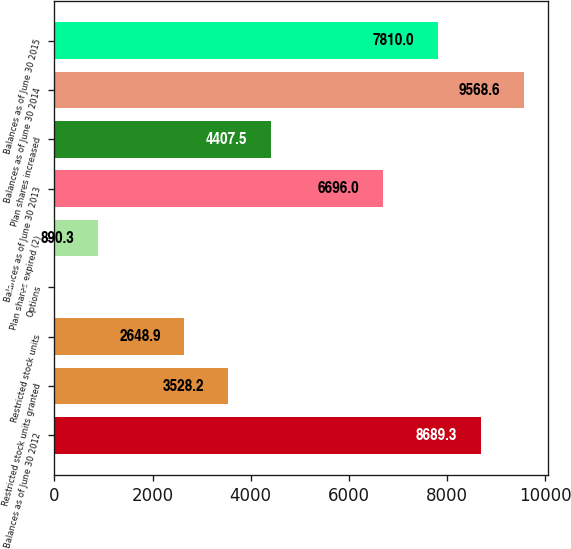Convert chart to OTSL. <chart><loc_0><loc_0><loc_500><loc_500><bar_chart><fcel>Balances as of June 30 2012<fcel>Restricted stock units granted<fcel>Restricted stock units<fcel>Options<fcel>Plan shares expired (2)<fcel>Balances as of June 30 2013<fcel>Plan shares increased<fcel>Balances as of June 30 2014<fcel>Balances as of June 30 2015<nl><fcel>8689.3<fcel>3528.2<fcel>2648.9<fcel>11<fcel>890.3<fcel>6696<fcel>4407.5<fcel>9568.6<fcel>7810<nl></chart> 